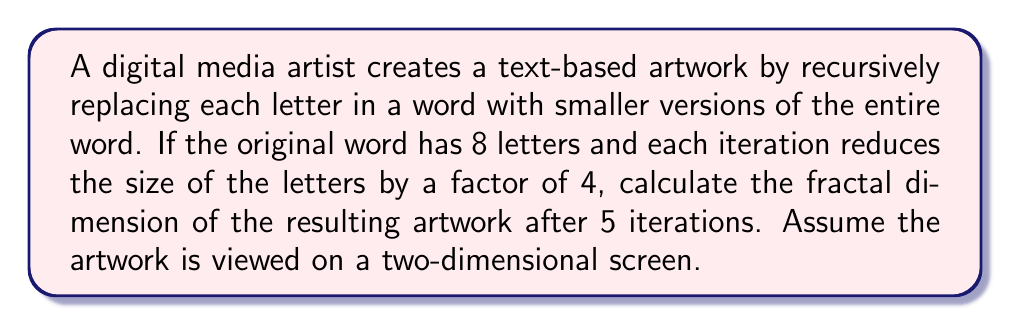What is the answer to this math problem? To calculate the fractal dimension of this text-based artwork, we'll use the box-counting method. The fractal dimension $D$ is given by the formula:

$$D = \frac{\log N}{\log(1/r)}$$

Where $N$ is the number of self-similar pieces, and $r$ is the scaling factor.

Let's break this down step-by-step:

1. In each iteration, every letter is replaced by the entire word.
   - Number of self-similar pieces: $N = 8$ (as the word has 8 letters)

2. The scaling factor is 1/4, as each iteration reduces the size by a factor of 4.
   - Scaling factor: $r = 1/4$

3. We need to consider 5 iterations, so we'll raise both $N$ and $1/r$ to the power of 5:
   - $N^5 = 8^5 = 32,768$
   - $(1/r)^5 = (4)^5 = 1,024$

4. Now we can apply the fractal dimension formula:

   $$D = \frac{\log(32,768)}{\log(1,024)}$$

5. Simplify:
   $$D = \frac{\log(2^{15})}{\log(2^{10})} = \frac{15\log(2)}{10\log(2)} = \frac{15}{10} = 1.5$$

The fractal dimension of 1.5 indicates that the artwork fills more space than a one-dimensional line (dimension 1) but less than a two-dimensional plane (dimension 2), which is consistent with the recursive, self-similar nature of the text-based artwork.
Answer: The fractal dimension of the text-based artwork after 5 iterations is 1.5. 